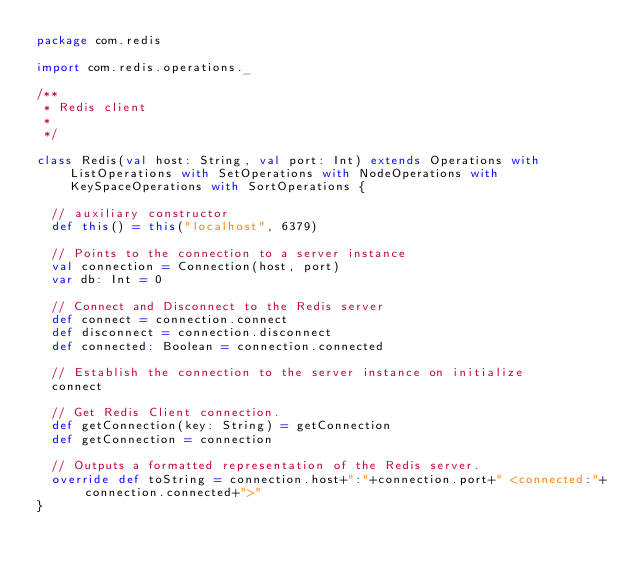<code> <loc_0><loc_0><loc_500><loc_500><_Scala_>package com.redis

import com.redis.operations._

/**
 * Redis client
 *
 */

class Redis(val host: String, val port: Int) extends Operations with ListOperations with SetOperations with NodeOperations with KeySpaceOperations with SortOperations {
  
  // auxiliary constructor
  def this() = this("localhost", 6379)
  
  // Points to the connection to a server instance
  val connection = Connection(host, port)
  var db: Int = 0
  
  // Connect and Disconnect to the Redis server
  def connect = connection.connect
  def disconnect = connection.disconnect
  def connected: Boolean = connection.connected
  
  // Establish the connection to the server instance on initialize
  connect
  
  // Get Redis Client connection.
  def getConnection(key: String) = getConnection
  def getConnection = connection
  
  // Outputs a formatted representation of the Redis server.
  override def toString = connection.host+":"+connection.port+" <connected:"+connection.connected+">"
}
</code> 